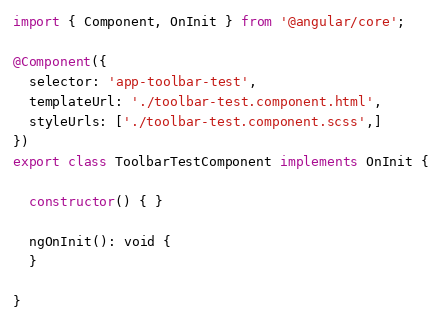Convert code to text. <code><loc_0><loc_0><loc_500><loc_500><_TypeScript_>import { Component, OnInit } from '@angular/core';

@Component({
  selector: 'app-toolbar-test',
  templateUrl: './toolbar-test.component.html',
  styleUrls: ['./toolbar-test.component.scss',]
})
export class ToolbarTestComponent implements OnInit {

  constructor() { }

  ngOnInit(): void {
  }

}
</code> 